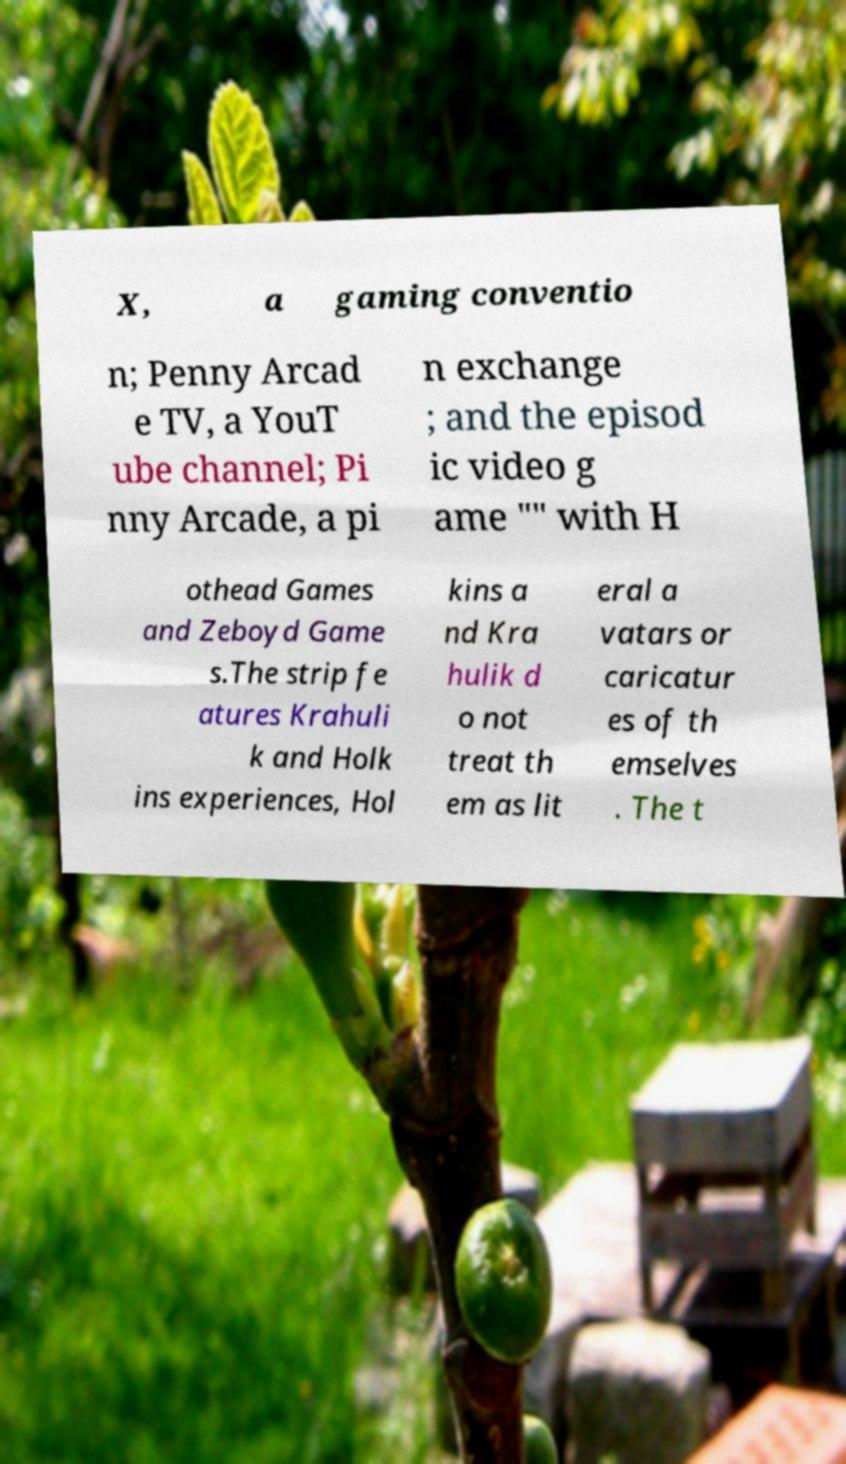Can you read and provide the text displayed in the image?This photo seems to have some interesting text. Can you extract and type it out for me? X, a gaming conventio n; Penny Arcad e TV, a YouT ube channel; Pi nny Arcade, a pi n exchange ; and the episod ic video g ame "" with H othead Games and Zeboyd Game s.The strip fe atures Krahuli k and Holk ins experiences, Hol kins a nd Kra hulik d o not treat th em as lit eral a vatars or caricatur es of th emselves . The t 